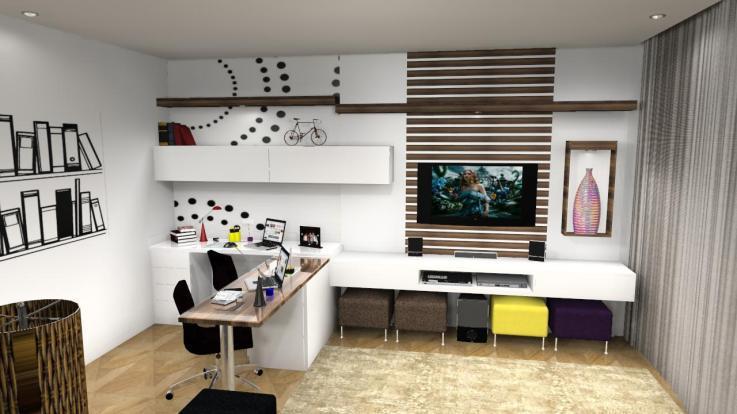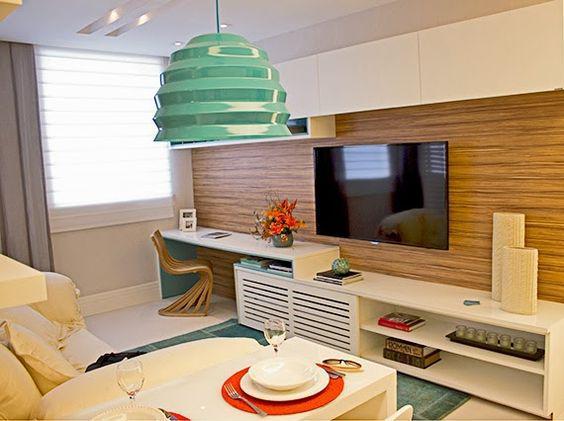The first image is the image on the left, the second image is the image on the right. For the images shown, is this caption "Curtains cover a window in the image on the left." true? Answer yes or no. No. The first image is the image on the left, the second image is the image on the right. For the images displayed, is the sentence "There is at least one light dangling from the ceiling." factually correct? Answer yes or no. Yes. 